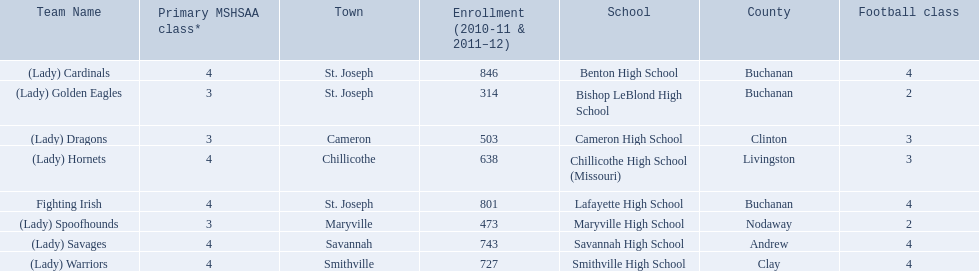What is the lowest number of students enrolled at a school as listed here? 314. What school has 314 students enrolled? Bishop LeBlond High School. 